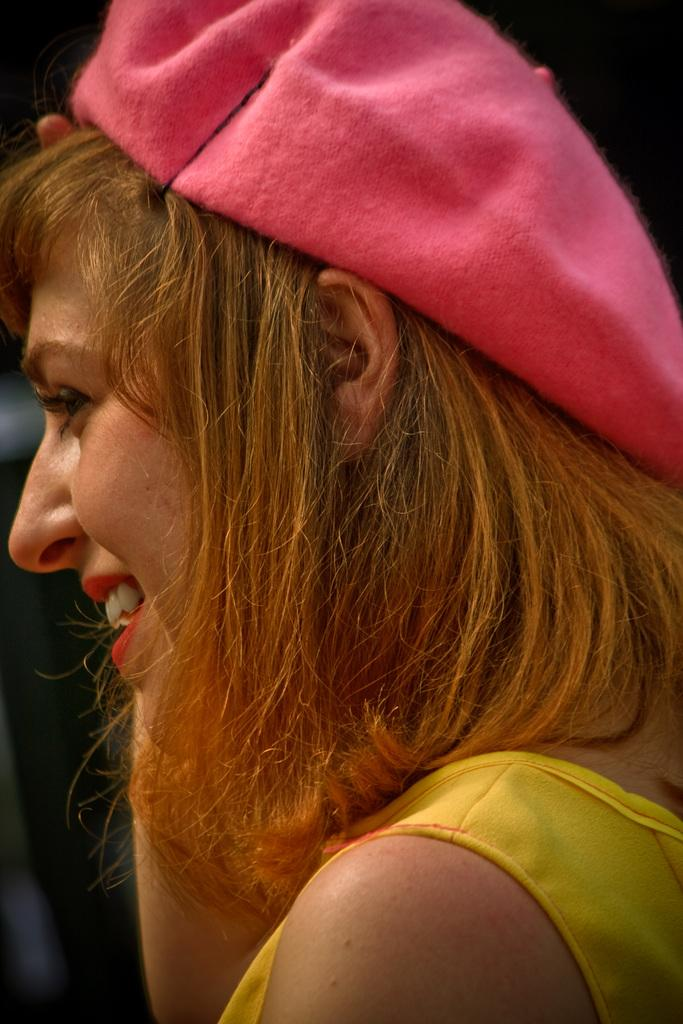Who is the main subject in the image? There is a woman in the image. What is the woman wearing on her head? The woman is wearing a pink cap. What is the woman's facial expression in the image? The woman is smiling. What can be observed about the background of the image? The background of the image is dark. What is the woman pointing at in the image? There is no indication in the image that the woman is pointing at anything. How many steps can be seen in the image? There are no steps visible in the image. 